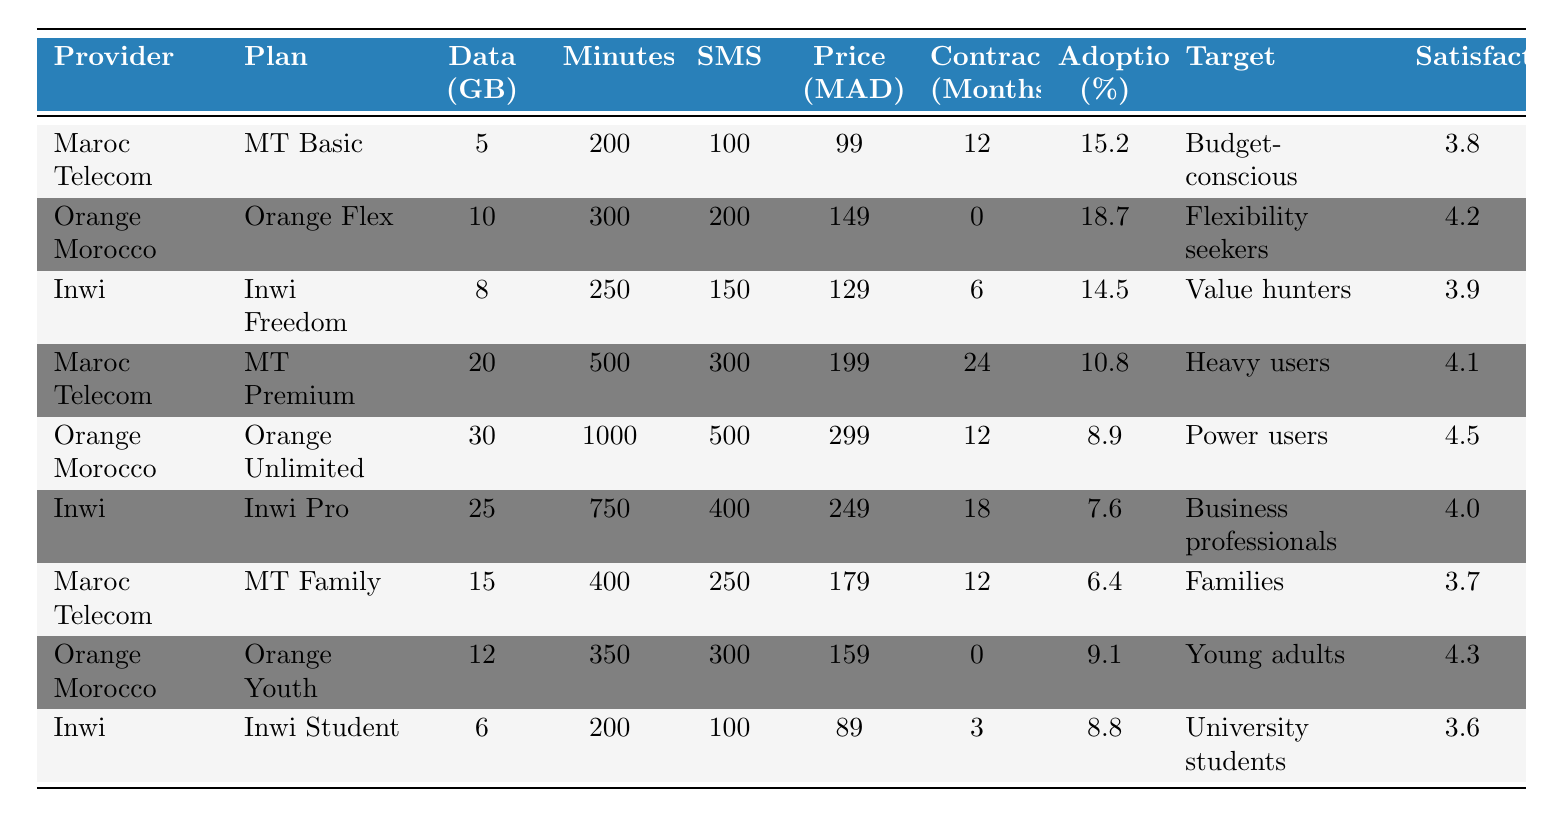What is the adoption rate for the Orange Flex plan? The adoption rate for the Orange Flex plan can be found in the "Adoption (%)" column corresponding to the "Orange Flex" plan under the "Plan" column. The value is 18.7%.
Answer: 18.7% Which service plan has the highest data allowance? Looking at the "Data (GB)" column, the Orange Unlimited plan has the highest data allowance with 30 GB.
Answer: 30 GB Is the MT Family plan more popular than the Inwi Freedom plan? Comparing the adoption rates from the "Adoption (%)" column, MT Family has an adoption rate of 6.4%, while Inwi Freedom has an adoption rate of 14.5%. Therefore, Inwi Freedom is more popular.
Answer: No What is the average customer satisfaction score for Maroc Telecom plans? The customer satisfaction scores for Maroc Telecom plans (MT Basic, MT Premium, and MT Family) are 3.8, 4.1, and 3.7, respectively. The sum is (3.8 + 4.1 + 3.7) = 11.6. Dividing by 3 gives an average satisfaction score of 11.6 / 3 = 3.867.
Answer: 3.867 Which provider offers the most plans? Counting the entries for each provider, Maroc Telecom has 3 plans, Orange Morocco has 3 plans, and Inwi has 3 plans. All providers have an equal number of plans.
Answer: None What is the total number of SMS included in the Orange Unlimited plan? The total number of SMS for the Orange Unlimited plan is listed in the "SMS" column next to the plan name. It shows a total of 500 SMS included.
Answer: 500 SMS What is the difference in the monthly price between the MT Premium and the Inwi Pro plans? To find the difference, subtract the monthly price of Inwi Pro (249 MAD) from the monthly price of MT Premium (199 MAD). The calculation is 199 - 249 = -50 MAD. Since we are asked for a difference, the absolute value is 50 MAD.
Answer: 50 MAD Which plan targets business professionals and what is its adoption rate? The plan targeting business professionals is Inwi Pro, and the corresponding adoption rate listed is 7.6%.
Answer: 7.6% What is the overall average monthly price of the plans listed? To calculate the overall average monthly price, sum all the monthly prices (99 + 149 + 129 + 199 + 299 + 249 + 179 + 159 + 89) = 1,460 MAD. There are 9 plans, so dividing gives 1,460 / 9 = 162.22 MAD.
Answer: 162.22 MAD Which plan has the lowest customer satisfaction score and what is that score? Reviewing the "Satisfaction" column, Inwi Student has the lowest score of 3.6.
Answer: 3.6 